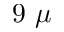Convert formula to latex. <formula><loc_0><loc_0><loc_500><loc_500>9 \ \mu</formula> 